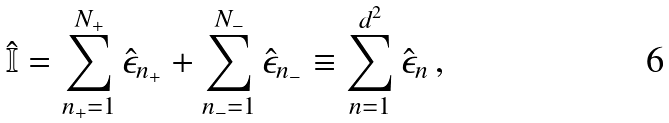Convert formula to latex. <formula><loc_0><loc_0><loc_500><loc_500>\hat { \mathbb { I } } = \sum _ { n _ { + } = 1 } ^ { N _ { + } } \hat { \epsilon } _ { n _ { + } } + \sum _ { n _ { - } = 1 } ^ { N _ { - } } \hat { \epsilon } _ { n _ { - } } \equiv \sum _ { n = 1 } ^ { d ^ { 2 } } \hat { \epsilon } _ { n } \, ,</formula> 